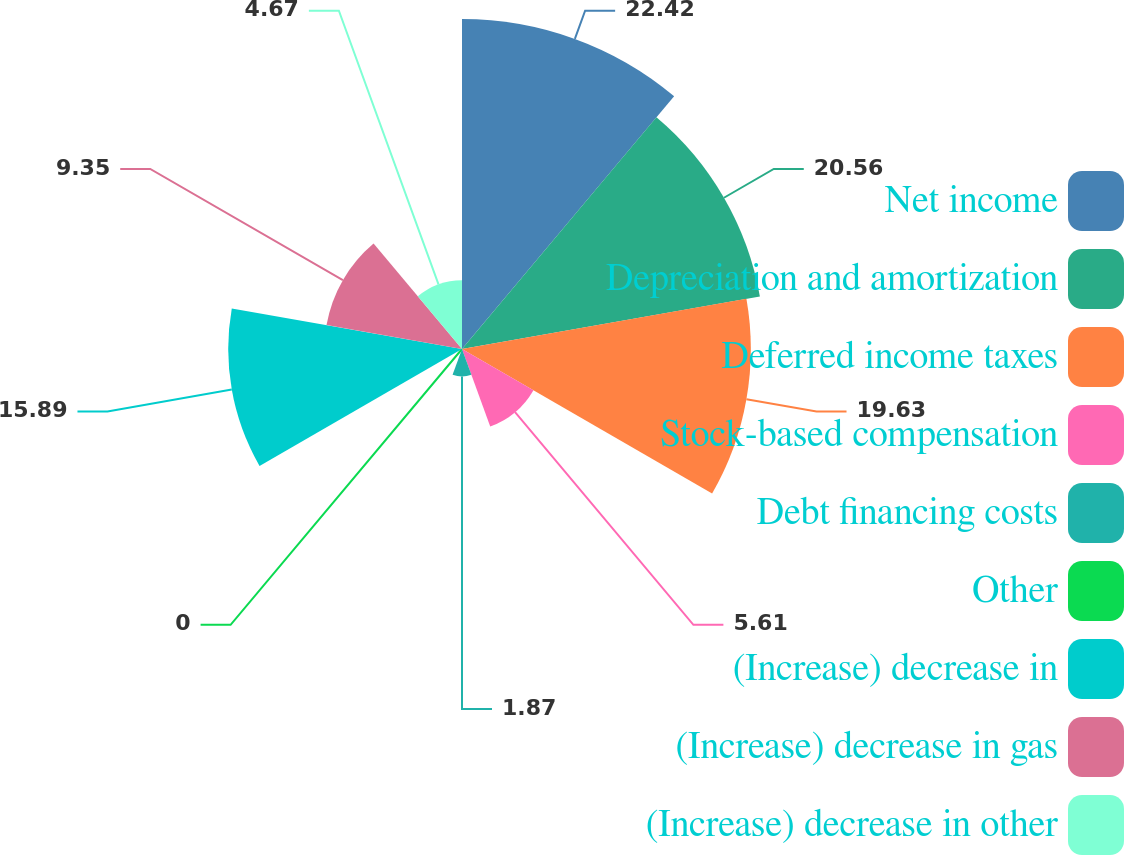Convert chart to OTSL. <chart><loc_0><loc_0><loc_500><loc_500><pie_chart><fcel>Net income<fcel>Depreciation and amortization<fcel>Deferred income taxes<fcel>Stock-based compensation<fcel>Debt financing costs<fcel>Other<fcel>(Increase) decrease in<fcel>(Increase) decrease in gas<fcel>(Increase) decrease in other<nl><fcel>22.43%<fcel>20.56%<fcel>19.63%<fcel>5.61%<fcel>1.87%<fcel>0.0%<fcel>15.89%<fcel>9.35%<fcel>4.67%<nl></chart> 